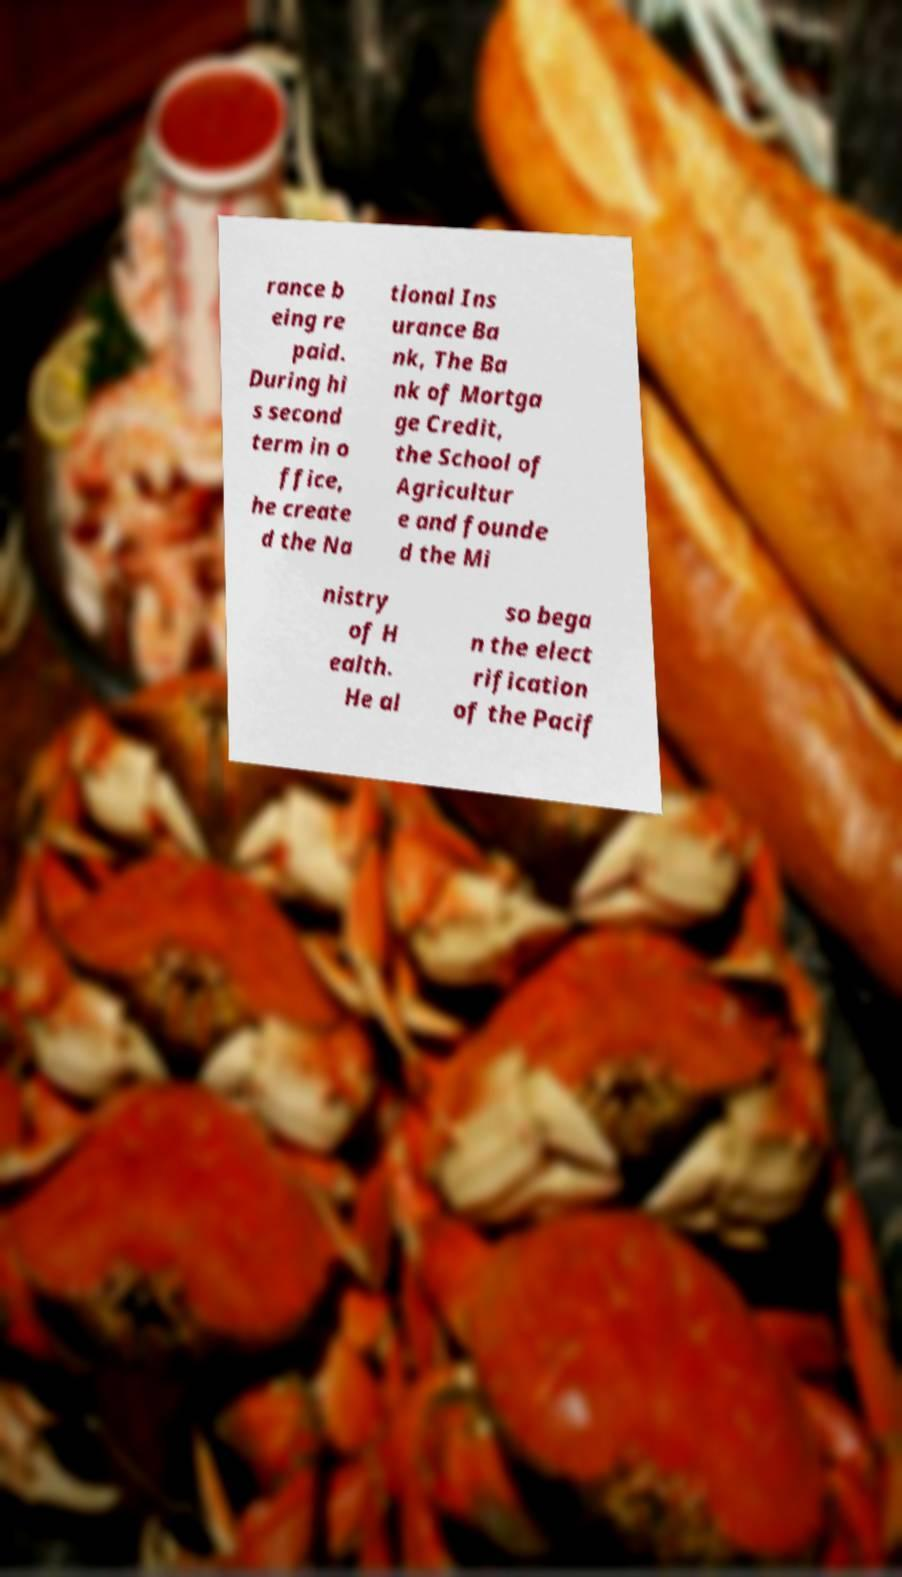For documentation purposes, I need the text within this image transcribed. Could you provide that? rance b eing re paid. During hi s second term in o ffice, he create d the Na tional Ins urance Ba nk, The Ba nk of Mortga ge Credit, the School of Agricultur e and founde d the Mi nistry of H ealth. He al so bega n the elect rification of the Pacif 